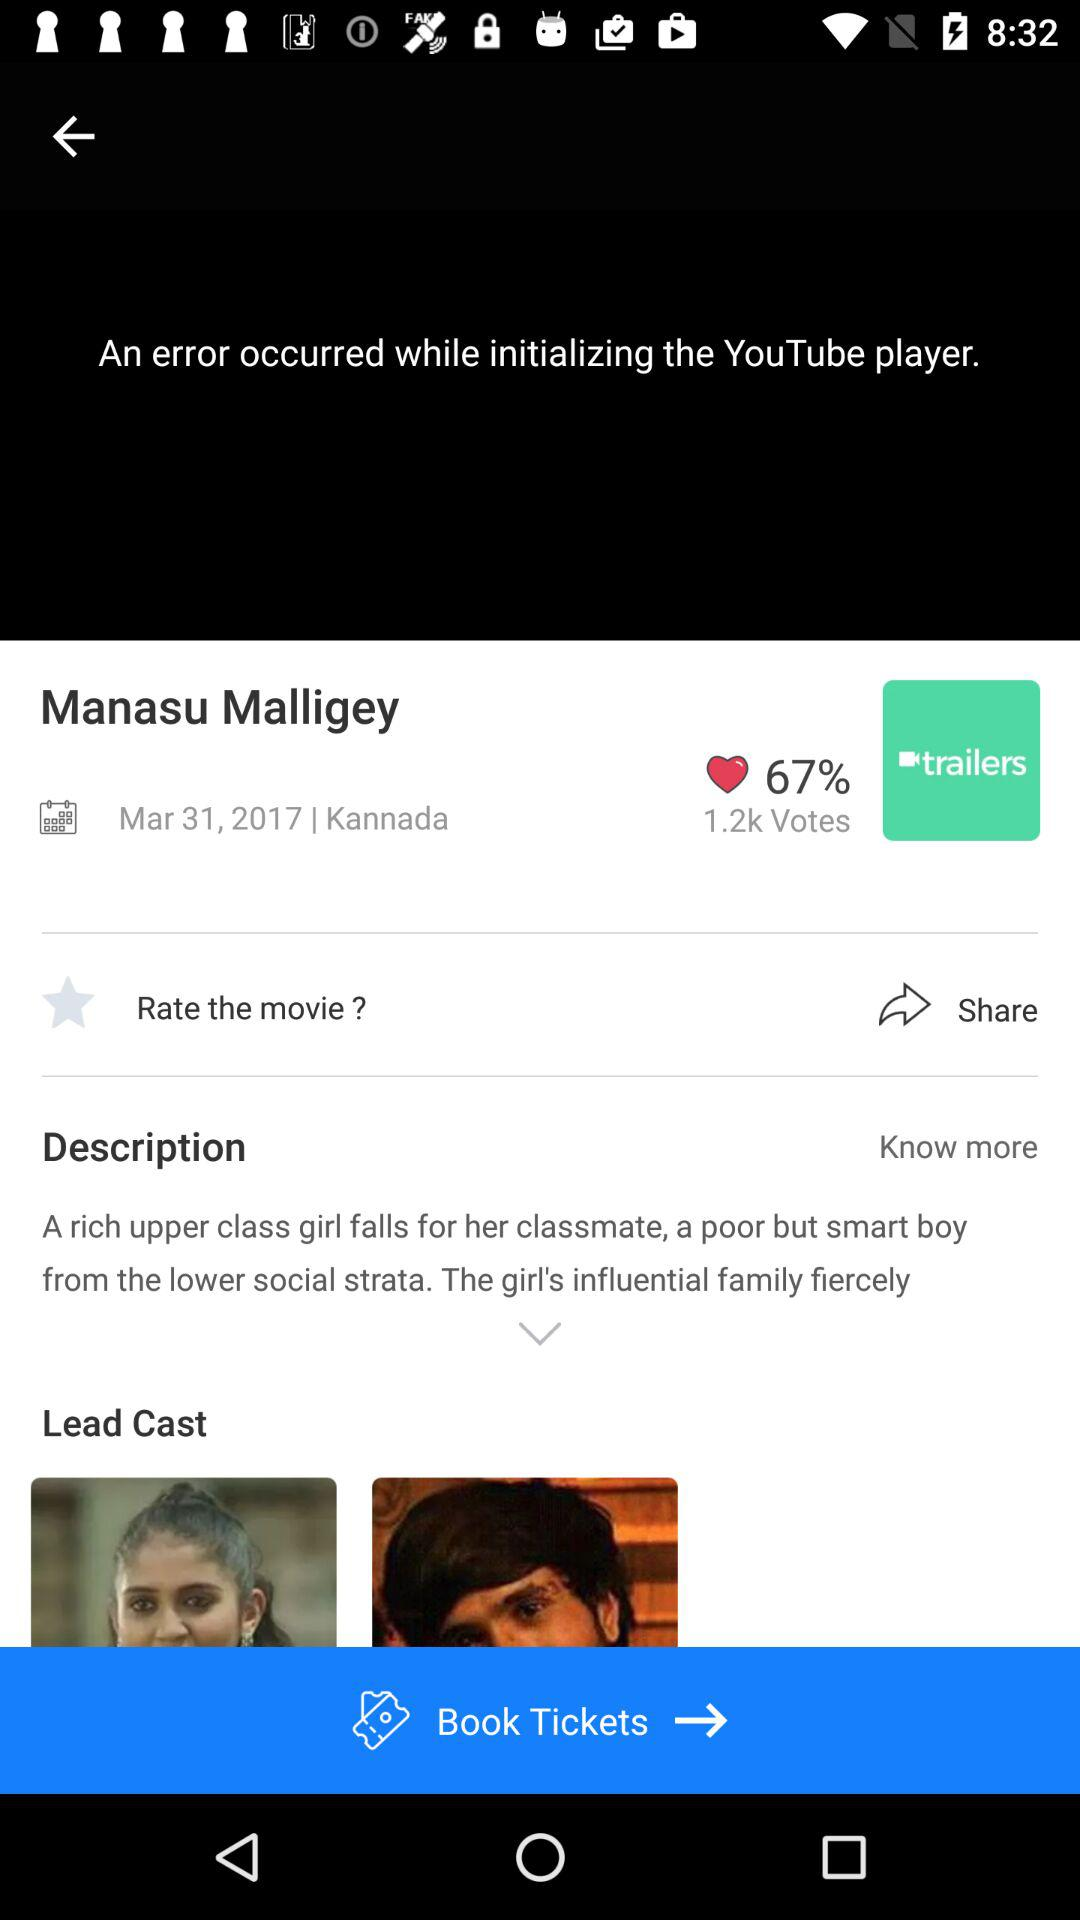How many votes are there? There are 1.2k votes. 